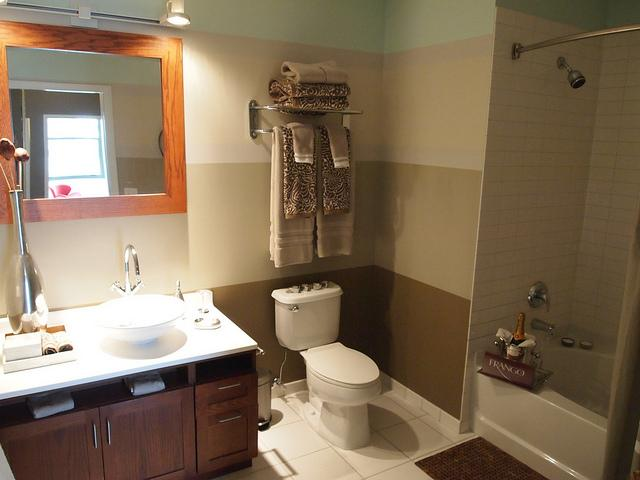What is on the rack sitting on the bathtub's edge?

Choices:
A) conditioner
B) soap
C) shampoo
D) wine wine 